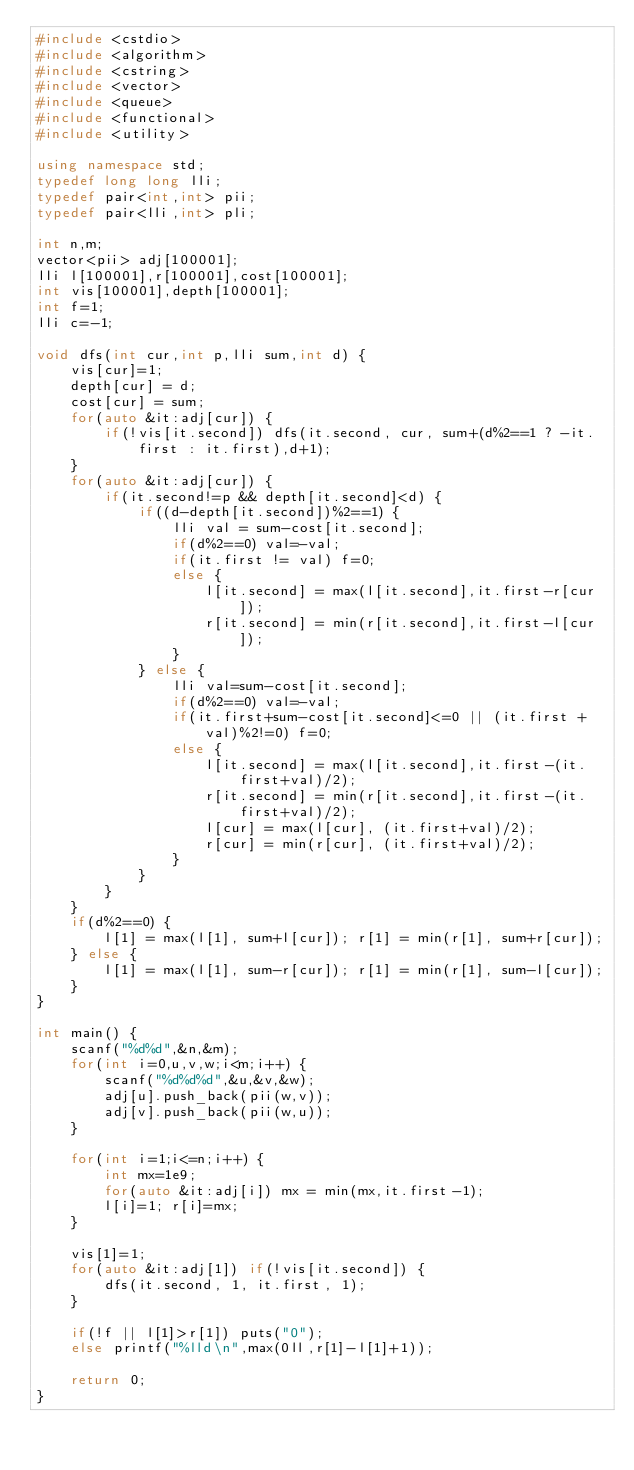<code> <loc_0><loc_0><loc_500><loc_500><_C++_>#include <cstdio>
#include <algorithm>
#include <cstring>
#include <vector>
#include <queue>
#include <functional>
#include <utility>

using namespace std;
typedef long long lli;
typedef pair<int,int> pii;
typedef pair<lli,int> pli;

int n,m;
vector<pii> adj[100001];
lli l[100001],r[100001],cost[100001];
int vis[100001],depth[100001];
int f=1;
lli c=-1;

void dfs(int cur,int p,lli sum,int d) {
	vis[cur]=1;
	depth[cur] = d;
	cost[cur] = sum;
	for(auto &it:adj[cur]) {
		if(!vis[it.second]) dfs(it.second, cur, sum+(d%2==1 ? -it.first : it.first),d+1);
	}
	for(auto &it:adj[cur]) {
		if(it.second!=p && depth[it.second]<d) {
			if((d-depth[it.second])%2==1) {
				lli val = sum-cost[it.second];
				if(d%2==0) val=-val;
				if(it.first != val) f=0;
				else {
					l[it.second] = max(l[it.second],it.first-r[cur]);
					r[it.second] = min(r[it.second],it.first-l[cur]);
				}
			} else {
				lli val=sum-cost[it.second];
				if(d%2==0) val=-val;
				if(it.first+sum-cost[it.second]<=0 || (it.first + val)%2!=0) f=0;
				else {
					l[it.second] = max(l[it.second],it.first-(it.first+val)/2);
					r[it.second] = min(r[it.second],it.first-(it.first+val)/2);
					l[cur] = max(l[cur], (it.first+val)/2);
					r[cur] = min(r[cur], (it.first+val)/2);
				}
			}
		}
	}
	if(d%2==0) {
		l[1] = max(l[1], sum+l[cur]); r[1] = min(r[1], sum+r[cur]);
	} else {
		l[1] = max(l[1], sum-r[cur]); r[1] = min(r[1], sum-l[cur]);
	}
}

int main() {
	scanf("%d%d",&n,&m);
	for(int i=0,u,v,w;i<m;i++) {
		scanf("%d%d%d",&u,&v,&w);
		adj[u].push_back(pii(w,v));
		adj[v].push_back(pii(w,u));
	}
	
	for(int i=1;i<=n;i++) {
		int mx=1e9;
		for(auto &it:adj[i]) mx = min(mx,it.first-1);
		l[i]=1; r[i]=mx;
	}
	
	vis[1]=1;
	for(auto &it:adj[1]) if(!vis[it.second]) {
		dfs(it.second, 1, it.first, 1);
	}

	if(!f || l[1]>r[1]) puts("0");
	else printf("%lld\n",max(0ll,r[1]-l[1]+1));
	
	return 0;
}
</code> 